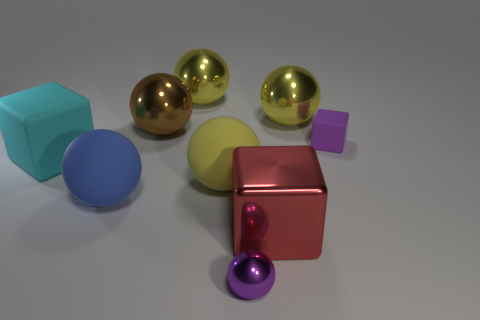Is there a yellow rubber sphere of the same size as the brown metallic object?
Offer a very short reply. Yes. There is a yellow shiny object on the right side of the yellow matte object; is its size the same as the small matte block?
Give a very brief answer. No. What shape is the object that is both to the right of the large red shiny thing and in front of the big brown metal thing?
Offer a terse response. Cube. Is the number of brown spheres that are to the right of the purple rubber block greater than the number of tiny purple metal balls?
Keep it short and to the point. No. What is the size of the other ball that is made of the same material as the blue sphere?
Your answer should be very brief. Large. How many other things have the same color as the tiny shiny object?
Your answer should be very brief. 1. Does the big matte ball that is to the right of the big blue rubber sphere have the same color as the small matte object?
Keep it short and to the point. No. Are there the same number of objects that are to the left of the red cube and brown metal balls that are behind the blue rubber sphere?
Provide a succinct answer. No. There is a large block that is in front of the big cyan matte block; what color is it?
Provide a short and direct response. Red. Are there the same number of purple objects that are in front of the red block and tiny rubber objects?
Provide a succinct answer. Yes. 